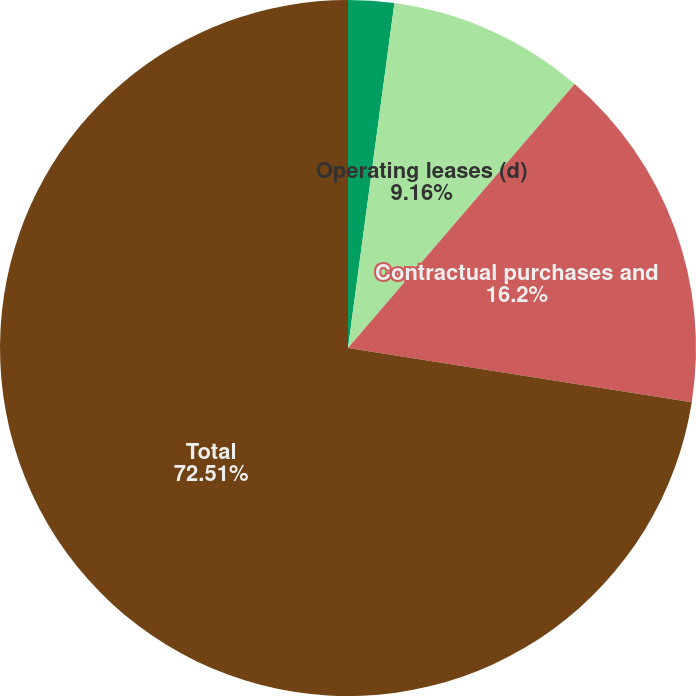Convert chart to OTSL. <chart><loc_0><loc_0><loc_500><loc_500><pie_chart><fcel>FIN 46 long-term beneficial<fcel>Operating leases (d)<fcel>Contractual purchases and<fcel>Total<nl><fcel>2.13%<fcel>9.16%<fcel>16.2%<fcel>72.51%<nl></chart> 